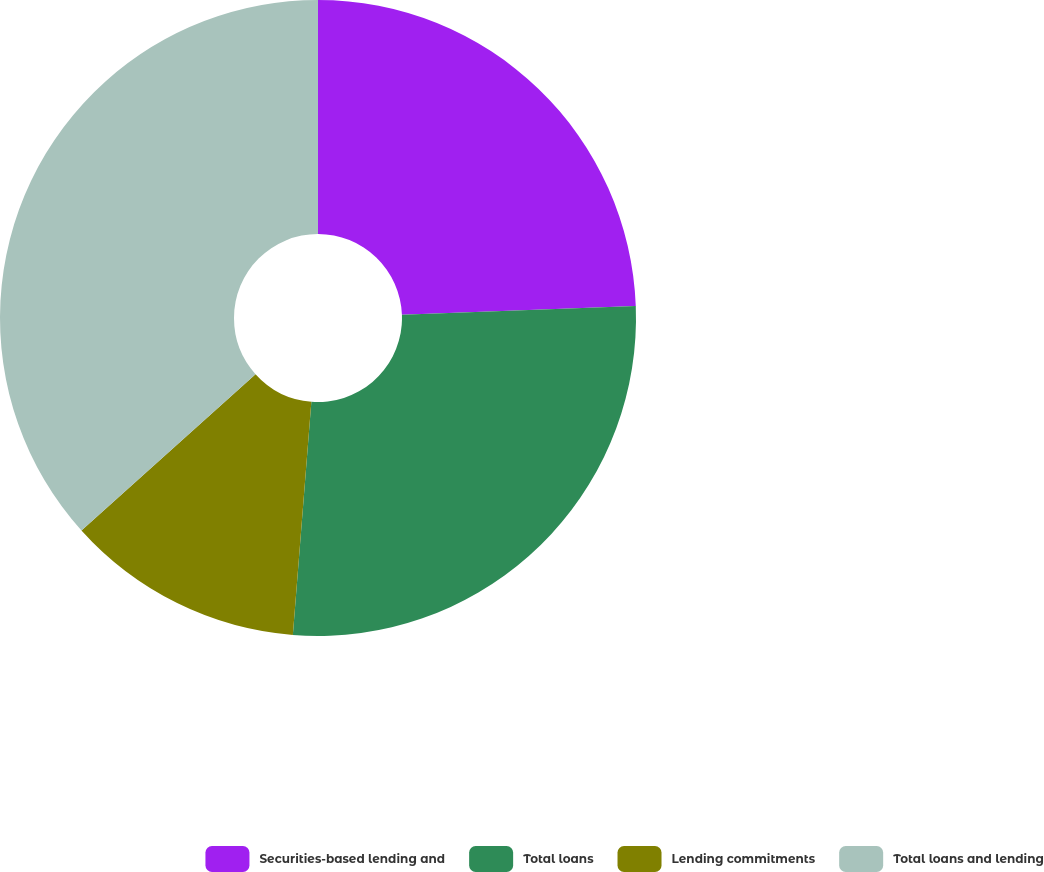Convert chart to OTSL. <chart><loc_0><loc_0><loc_500><loc_500><pie_chart><fcel>Securities-based lending and<fcel>Total loans<fcel>Lending commitments<fcel>Total loans and lending<nl><fcel>24.4%<fcel>26.86%<fcel>12.09%<fcel>36.65%<nl></chart> 